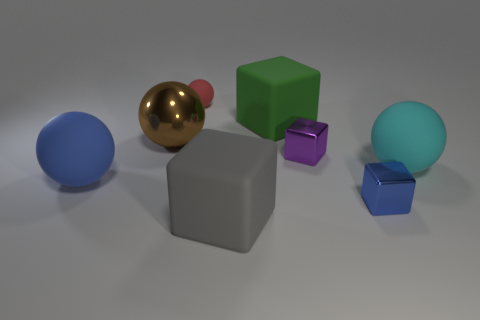Subtract 1 spheres. How many spheres are left? 3 Add 2 red things. How many objects exist? 10 Subtract 0 gray balls. How many objects are left? 8 Subtract all big gray things. Subtract all cyan matte balls. How many objects are left? 6 Add 8 matte cubes. How many matte cubes are left? 10 Add 2 small purple metal things. How many small purple metal things exist? 3 